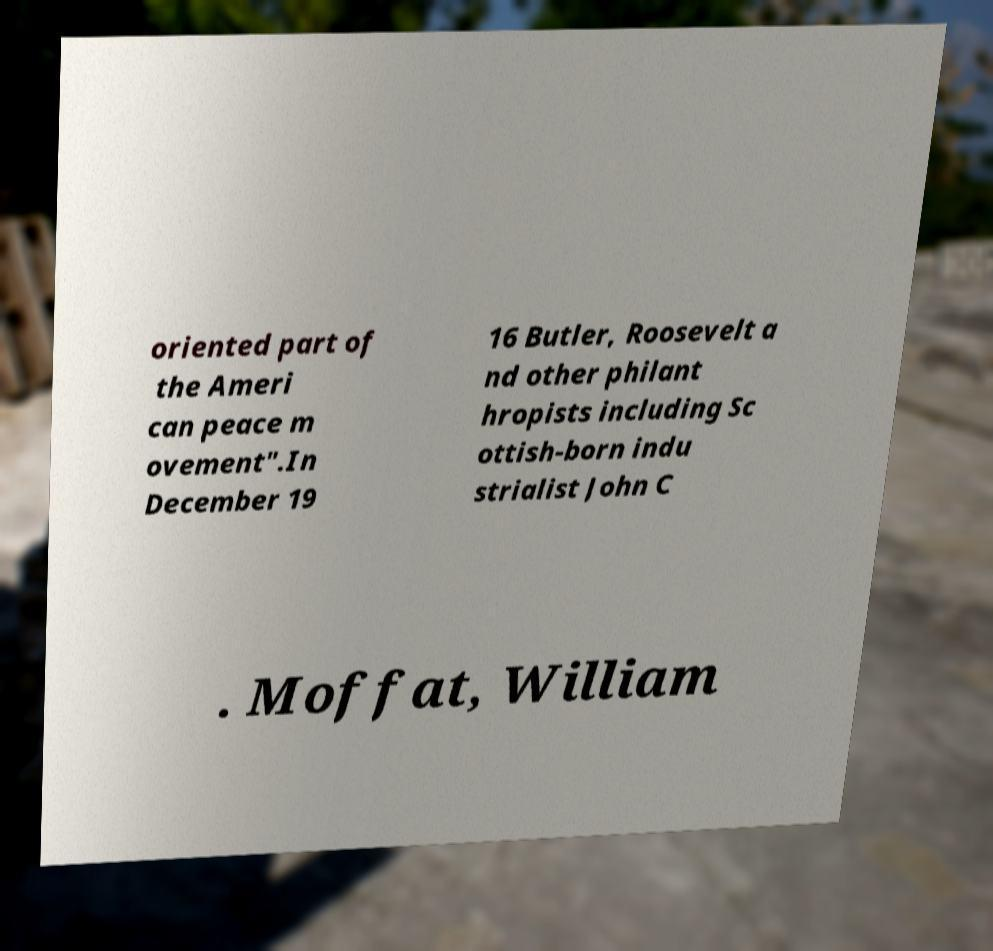Could you assist in decoding the text presented in this image and type it out clearly? oriented part of the Ameri can peace m ovement".In December 19 16 Butler, Roosevelt a nd other philant hropists including Sc ottish-born indu strialist John C . Moffat, William 